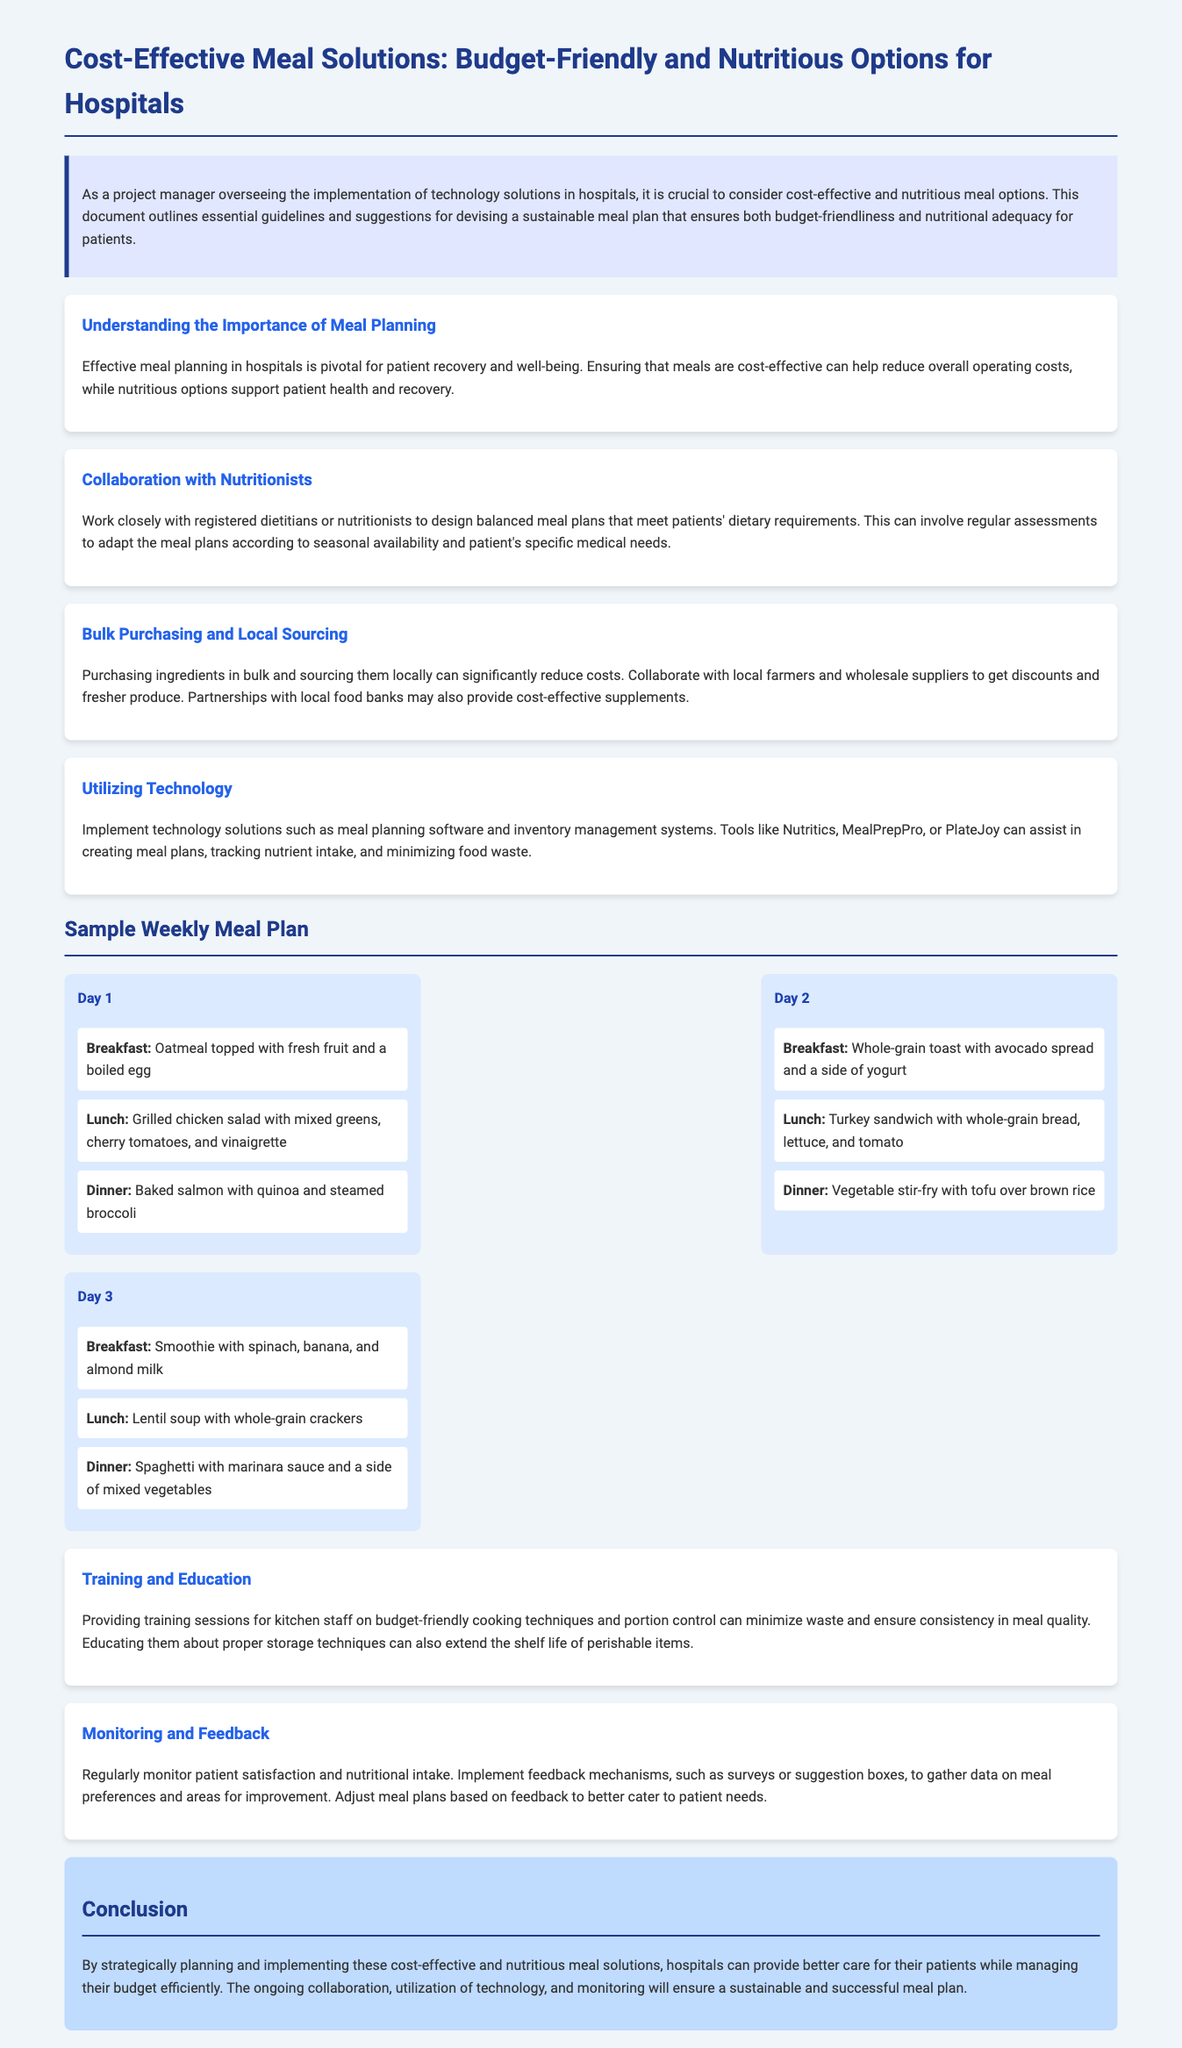What is the title of the document? The title appears at the top of the document and indicates the main subject.
Answer: Cost-Effective Meal Solutions: Budget-Friendly and Nutritious Options for Hospitals What are the key points discussed in the document? The document highlights specific areas for improving meal planning, which are categorized as key points.
Answer: Understanding the Importance of Meal Planning, Collaboration with Nutritionists, Bulk Purchasing and Local Sourcing, Utilizing Technology, Training and Education, Monitoring and Feedback How many meals are proposed in the sample weekly meal plan? The document lists various meals across several days in the meal plan section.
Answer: 9 What is included in the Day 1 dinner? The Day 1 dinner meal option is provided in the meal plan section.
Answer: Baked salmon with quinoa and steamed broccoli What is one suggested technology solution mentioned? The document includes various technological tools that can assist in meal planning and inventory management.
Answer: Nutritics What is emphasized regarding collaboration in meal planning? The document discusses the role of professionals in ensuring meals meet specific dietary needs.
Answer: Work closely with registered dietitians or nutritionists What is a benefit of bulk purchasing mentioned in the document? The document explains how sourcing ingredients in a particular way can impact costs.
Answer: Significantly reduce costs How can patient satisfaction be monitored according to the document? The document suggests methods for gathering feedback on meals to enhance patient experience.
Answer: Surveys or suggestion boxes What is the primary goal of implementing the meal plan strategies? The document concludes with a statement about the broader aim of efficient meal planning.
Answer: Better care for patients while managing budget efficiently 